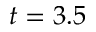<formula> <loc_0><loc_0><loc_500><loc_500>t = 3 . 5</formula> 